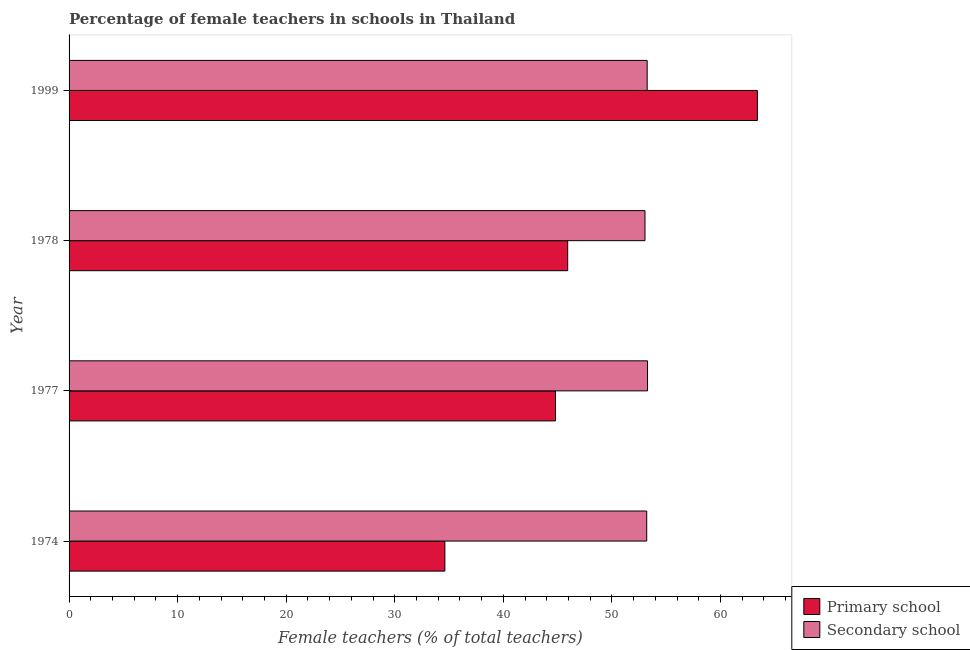How many groups of bars are there?
Provide a short and direct response. 4. Are the number of bars per tick equal to the number of legend labels?
Provide a short and direct response. Yes. What is the label of the 3rd group of bars from the top?
Provide a short and direct response. 1977. In how many cases, is the number of bars for a given year not equal to the number of legend labels?
Your response must be concise. 0. What is the percentage of female teachers in secondary schools in 1974?
Your answer should be compact. 53.2. Across all years, what is the maximum percentage of female teachers in secondary schools?
Make the answer very short. 53.27. Across all years, what is the minimum percentage of female teachers in primary schools?
Your answer should be compact. 34.61. In which year was the percentage of female teachers in secondary schools maximum?
Your answer should be very brief. 1977. In which year was the percentage of female teachers in primary schools minimum?
Keep it short and to the point. 1974. What is the total percentage of female teachers in primary schools in the graph?
Ensure brevity in your answer.  188.73. What is the difference between the percentage of female teachers in primary schools in 1974 and that in 1978?
Keep it short and to the point. -11.31. What is the difference between the percentage of female teachers in secondary schools in 1999 and the percentage of female teachers in primary schools in 1978?
Your answer should be compact. 7.32. What is the average percentage of female teachers in primary schools per year?
Offer a terse response. 47.18. In the year 1999, what is the difference between the percentage of female teachers in primary schools and percentage of female teachers in secondary schools?
Your response must be concise. 10.15. In how many years, is the percentage of female teachers in secondary schools greater than 52 %?
Offer a very short reply. 4. What is the ratio of the percentage of female teachers in primary schools in 1977 to that in 1999?
Provide a succinct answer. 0.71. Is the percentage of female teachers in primary schools in 1977 less than that in 1999?
Provide a short and direct response. Yes. Is the difference between the percentage of female teachers in primary schools in 1974 and 1999 greater than the difference between the percentage of female teachers in secondary schools in 1974 and 1999?
Offer a terse response. No. What is the difference between the highest and the second highest percentage of female teachers in secondary schools?
Your response must be concise. 0.03. What is the difference between the highest and the lowest percentage of female teachers in primary schools?
Keep it short and to the point. 28.78. In how many years, is the percentage of female teachers in primary schools greater than the average percentage of female teachers in primary schools taken over all years?
Offer a terse response. 1. Is the sum of the percentage of female teachers in secondary schools in 1974 and 1977 greater than the maximum percentage of female teachers in primary schools across all years?
Keep it short and to the point. Yes. What does the 2nd bar from the top in 1978 represents?
Make the answer very short. Primary school. What does the 1st bar from the bottom in 1999 represents?
Offer a terse response. Primary school. Are all the bars in the graph horizontal?
Keep it short and to the point. Yes. What is the difference between two consecutive major ticks on the X-axis?
Your response must be concise. 10. Does the graph contain any zero values?
Keep it short and to the point. No. Does the graph contain grids?
Give a very brief answer. No. Where does the legend appear in the graph?
Provide a short and direct response. Bottom right. How are the legend labels stacked?
Your answer should be very brief. Vertical. What is the title of the graph?
Your answer should be compact. Percentage of female teachers in schools in Thailand. Does "Adolescent fertility rate" appear as one of the legend labels in the graph?
Your answer should be compact. No. What is the label or title of the X-axis?
Your answer should be very brief. Female teachers (% of total teachers). What is the label or title of the Y-axis?
Your response must be concise. Year. What is the Female teachers (% of total teachers) in Primary school in 1974?
Your answer should be very brief. 34.61. What is the Female teachers (% of total teachers) of Secondary school in 1974?
Ensure brevity in your answer.  53.2. What is the Female teachers (% of total teachers) of Primary school in 1977?
Your answer should be compact. 44.8. What is the Female teachers (% of total teachers) in Secondary school in 1977?
Offer a very short reply. 53.27. What is the Female teachers (% of total teachers) in Primary school in 1978?
Give a very brief answer. 45.92. What is the Female teachers (% of total teachers) of Secondary school in 1978?
Make the answer very short. 53.04. What is the Female teachers (% of total teachers) of Primary school in 1999?
Provide a short and direct response. 63.39. What is the Female teachers (% of total teachers) of Secondary school in 1999?
Offer a very short reply. 53.24. Across all years, what is the maximum Female teachers (% of total teachers) of Primary school?
Your response must be concise. 63.39. Across all years, what is the maximum Female teachers (% of total teachers) in Secondary school?
Give a very brief answer. 53.27. Across all years, what is the minimum Female teachers (% of total teachers) in Primary school?
Make the answer very short. 34.61. Across all years, what is the minimum Female teachers (% of total teachers) in Secondary school?
Offer a terse response. 53.04. What is the total Female teachers (% of total teachers) of Primary school in the graph?
Ensure brevity in your answer.  188.73. What is the total Female teachers (% of total teachers) in Secondary school in the graph?
Offer a very short reply. 212.76. What is the difference between the Female teachers (% of total teachers) in Primary school in 1974 and that in 1977?
Give a very brief answer. -10.19. What is the difference between the Female teachers (% of total teachers) of Secondary school in 1974 and that in 1977?
Your response must be concise. -0.07. What is the difference between the Female teachers (% of total teachers) in Primary school in 1974 and that in 1978?
Provide a succinct answer. -11.31. What is the difference between the Female teachers (% of total teachers) of Secondary school in 1974 and that in 1978?
Provide a short and direct response. 0.16. What is the difference between the Female teachers (% of total teachers) of Primary school in 1974 and that in 1999?
Make the answer very short. -28.78. What is the difference between the Female teachers (% of total teachers) of Secondary school in 1974 and that in 1999?
Make the answer very short. -0.04. What is the difference between the Female teachers (% of total teachers) in Primary school in 1977 and that in 1978?
Give a very brief answer. -1.12. What is the difference between the Female teachers (% of total teachers) in Secondary school in 1977 and that in 1978?
Provide a short and direct response. 0.23. What is the difference between the Female teachers (% of total teachers) in Primary school in 1977 and that in 1999?
Provide a succinct answer. -18.59. What is the difference between the Female teachers (% of total teachers) in Secondary school in 1977 and that in 1999?
Offer a terse response. 0.03. What is the difference between the Female teachers (% of total teachers) in Primary school in 1978 and that in 1999?
Keep it short and to the point. -17.47. What is the difference between the Female teachers (% of total teachers) in Secondary school in 1978 and that in 1999?
Make the answer very short. -0.2. What is the difference between the Female teachers (% of total teachers) of Primary school in 1974 and the Female teachers (% of total teachers) of Secondary school in 1977?
Offer a very short reply. -18.66. What is the difference between the Female teachers (% of total teachers) of Primary school in 1974 and the Female teachers (% of total teachers) of Secondary school in 1978?
Provide a short and direct response. -18.43. What is the difference between the Female teachers (% of total teachers) in Primary school in 1974 and the Female teachers (% of total teachers) in Secondary school in 1999?
Make the answer very short. -18.63. What is the difference between the Female teachers (% of total teachers) of Primary school in 1977 and the Female teachers (% of total teachers) of Secondary school in 1978?
Ensure brevity in your answer.  -8.24. What is the difference between the Female teachers (% of total teachers) in Primary school in 1977 and the Female teachers (% of total teachers) in Secondary school in 1999?
Your answer should be compact. -8.44. What is the difference between the Female teachers (% of total teachers) in Primary school in 1978 and the Female teachers (% of total teachers) in Secondary school in 1999?
Give a very brief answer. -7.32. What is the average Female teachers (% of total teachers) of Primary school per year?
Offer a very short reply. 47.18. What is the average Female teachers (% of total teachers) of Secondary school per year?
Your answer should be compact. 53.19. In the year 1974, what is the difference between the Female teachers (% of total teachers) in Primary school and Female teachers (% of total teachers) in Secondary school?
Give a very brief answer. -18.59. In the year 1977, what is the difference between the Female teachers (% of total teachers) in Primary school and Female teachers (% of total teachers) in Secondary school?
Offer a very short reply. -8.47. In the year 1978, what is the difference between the Female teachers (% of total teachers) in Primary school and Female teachers (% of total teachers) in Secondary school?
Provide a short and direct response. -7.12. In the year 1999, what is the difference between the Female teachers (% of total teachers) of Primary school and Female teachers (% of total teachers) of Secondary school?
Keep it short and to the point. 10.15. What is the ratio of the Female teachers (% of total teachers) in Primary school in 1974 to that in 1977?
Your answer should be very brief. 0.77. What is the ratio of the Female teachers (% of total teachers) in Secondary school in 1974 to that in 1977?
Ensure brevity in your answer.  1. What is the ratio of the Female teachers (% of total teachers) in Primary school in 1974 to that in 1978?
Offer a terse response. 0.75. What is the ratio of the Female teachers (% of total teachers) of Primary school in 1974 to that in 1999?
Ensure brevity in your answer.  0.55. What is the ratio of the Female teachers (% of total teachers) in Secondary school in 1974 to that in 1999?
Your answer should be compact. 1. What is the ratio of the Female teachers (% of total teachers) in Primary school in 1977 to that in 1978?
Your answer should be compact. 0.98. What is the ratio of the Female teachers (% of total teachers) of Primary school in 1977 to that in 1999?
Offer a very short reply. 0.71. What is the ratio of the Female teachers (% of total teachers) in Primary school in 1978 to that in 1999?
Provide a short and direct response. 0.72. What is the ratio of the Female teachers (% of total teachers) in Secondary school in 1978 to that in 1999?
Give a very brief answer. 1. What is the difference between the highest and the second highest Female teachers (% of total teachers) of Primary school?
Your response must be concise. 17.47. What is the difference between the highest and the second highest Female teachers (% of total teachers) in Secondary school?
Provide a short and direct response. 0.03. What is the difference between the highest and the lowest Female teachers (% of total teachers) in Primary school?
Ensure brevity in your answer.  28.78. What is the difference between the highest and the lowest Female teachers (% of total teachers) of Secondary school?
Your response must be concise. 0.23. 